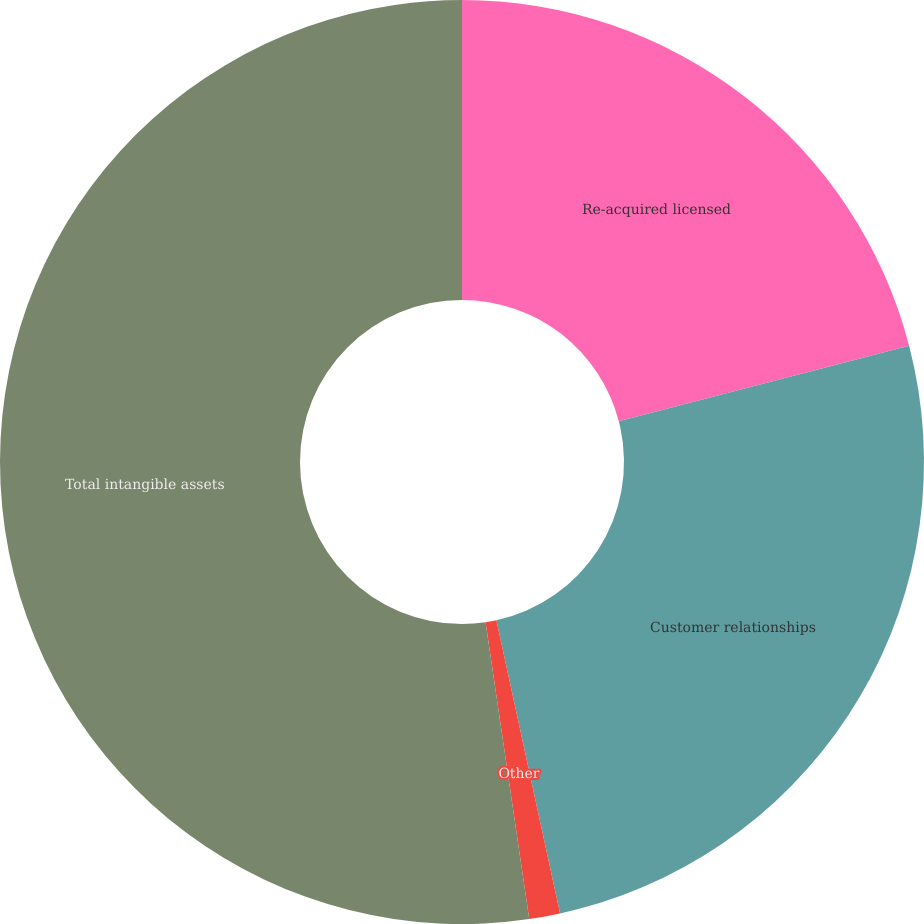Convert chart to OTSL. <chart><loc_0><loc_0><loc_500><loc_500><pie_chart><fcel>Re-acquired licensed<fcel>Customer relationships<fcel>Other<fcel>Total intangible assets<nl><fcel>20.95%<fcel>25.65%<fcel>1.08%<fcel>52.33%<nl></chart> 